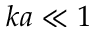Convert formula to latex. <formula><loc_0><loc_0><loc_500><loc_500>k a \ll 1</formula> 